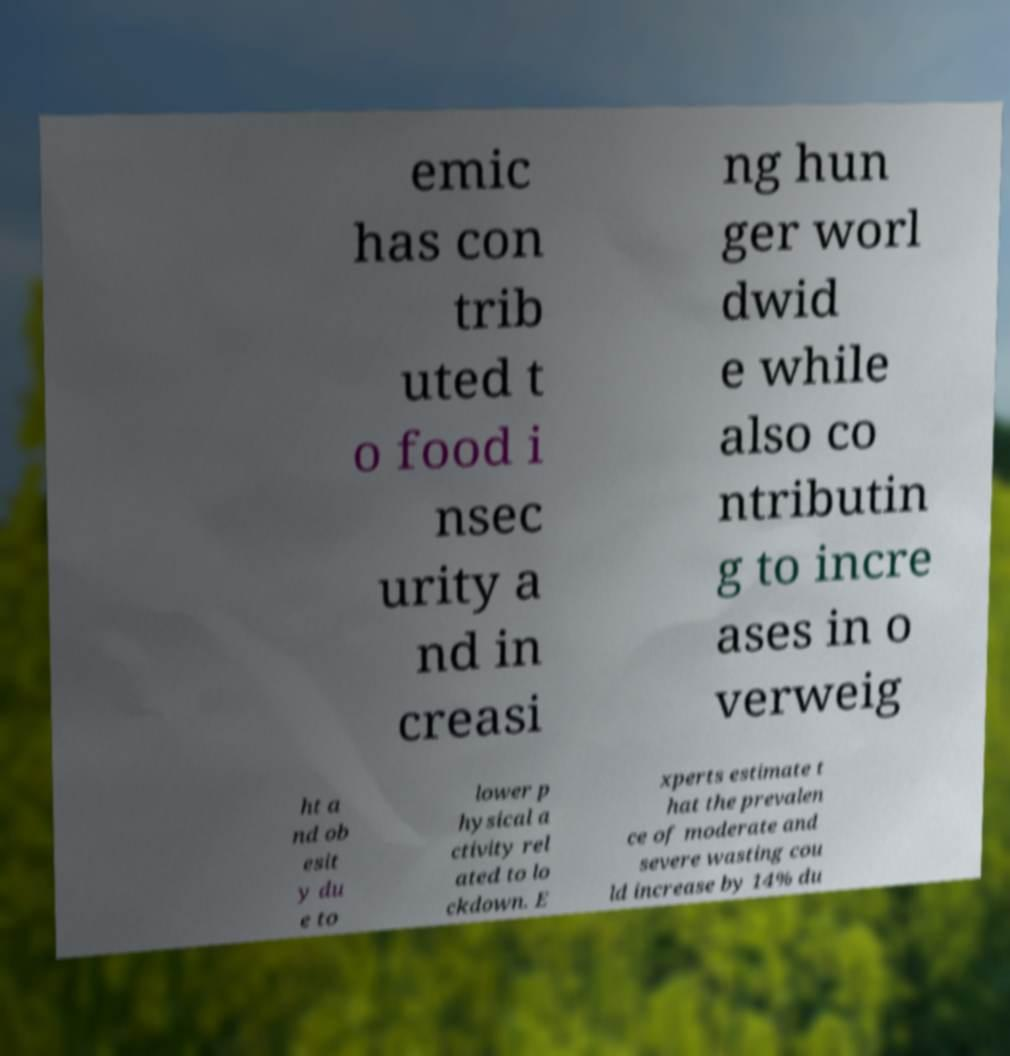Could you extract and type out the text from this image? emic has con trib uted t o food i nsec urity a nd in creasi ng hun ger worl dwid e while also co ntributin g to incre ases in o verweig ht a nd ob esit y du e to lower p hysical a ctivity rel ated to lo ckdown. E xperts estimate t hat the prevalen ce of moderate and severe wasting cou ld increase by 14% du 